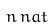<formula> <loc_0><loc_0><loc_500><loc_500>n \, { n a t }</formula> 